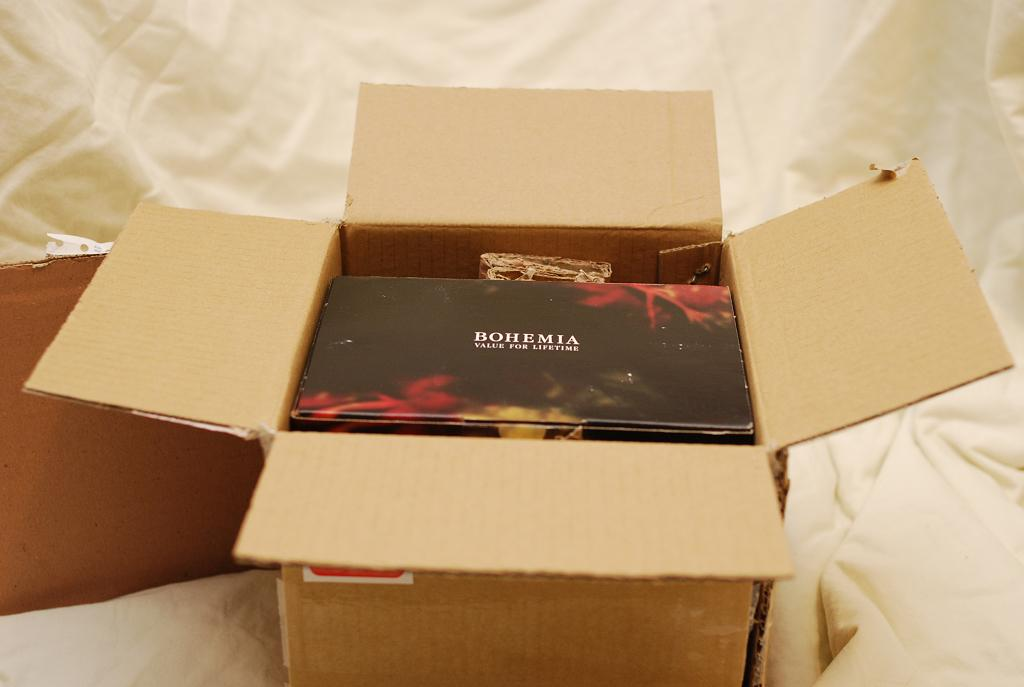<image>
Render a clear and concise summary of the photo. A black box saying BOHEMIA VALUE FOR A LIFETIME sits inside an open cardboard shipping box. 